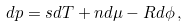Convert formula to latex. <formula><loc_0><loc_0><loc_500><loc_500>d p = s d T + n d \mu - R d \phi \, ,</formula> 